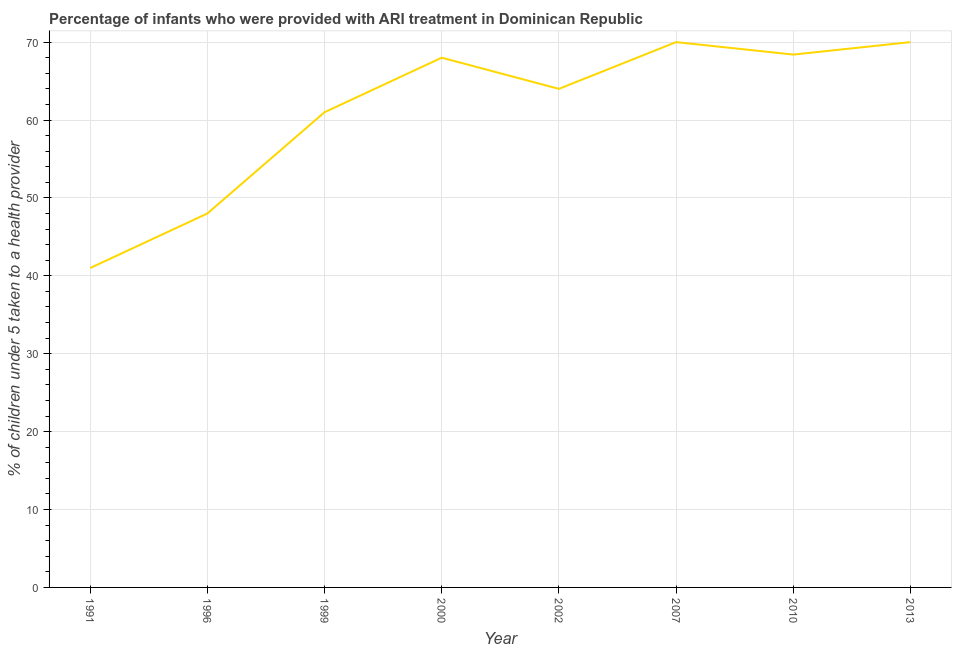What is the percentage of children who were provided with ari treatment in 2010?
Make the answer very short. 68.4. Across all years, what is the maximum percentage of children who were provided with ari treatment?
Your answer should be very brief. 70. In which year was the percentage of children who were provided with ari treatment minimum?
Your answer should be compact. 1991. What is the sum of the percentage of children who were provided with ari treatment?
Give a very brief answer. 490.4. What is the difference between the percentage of children who were provided with ari treatment in 1991 and 2010?
Your answer should be compact. -27.4. What is the average percentage of children who were provided with ari treatment per year?
Ensure brevity in your answer.  61.3. In how many years, is the percentage of children who were provided with ari treatment greater than 54 %?
Your response must be concise. 6. Do a majority of the years between 2000 and 2002 (inclusive) have percentage of children who were provided with ari treatment greater than 60 %?
Give a very brief answer. Yes. What is the ratio of the percentage of children who were provided with ari treatment in 2000 to that in 2013?
Your response must be concise. 0.97. What is the difference between the highest and the lowest percentage of children who were provided with ari treatment?
Ensure brevity in your answer.  29. In how many years, is the percentage of children who were provided with ari treatment greater than the average percentage of children who were provided with ari treatment taken over all years?
Your answer should be compact. 5. Are the values on the major ticks of Y-axis written in scientific E-notation?
Make the answer very short. No. What is the title of the graph?
Ensure brevity in your answer.  Percentage of infants who were provided with ARI treatment in Dominican Republic. What is the label or title of the Y-axis?
Provide a short and direct response. % of children under 5 taken to a health provider. What is the % of children under 5 taken to a health provider in 1991?
Your response must be concise. 41. What is the % of children under 5 taken to a health provider of 1999?
Your answer should be compact. 61. What is the % of children under 5 taken to a health provider in 2007?
Give a very brief answer. 70. What is the % of children under 5 taken to a health provider in 2010?
Your answer should be very brief. 68.4. What is the % of children under 5 taken to a health provider of 2013?
Keep it short and to the point. 70. What is the difference between the % of children under 5 taken to a health provider in 1991 and 1999?
Make the answer very short. -20. What is the difference between the % of children under 5 taken to a health provider in 1991 and 2000?
Your response must be concise. -27. What is the difference between the % of children under 5 taken to a health provider in 1991 and 2002?
Provide a short and direct response. -23. What is the difference between the % of children under 5 taken to a health provider in 1991 and 2010?
Offer a terse response. -27.4. What is the difference between the % of children under 5 taken to a health provider in 1991 and 2013?
Give a very brief answer. -29. What is the difference between the % of children under 5 taken to a health provider in 1996 and 2002?
Your answer should be compact. -16. What is the difference between the % of children under 5 taken to a health provider in 1996 and 2010?
Give a very brief answer. -20.4. What is the difference between the % of children under 5 taken to a health provider in 1999 and 2010?
Your response must be concise. -7.4. What is the difference between the % of children under 5 taken to a health provider in 2000 and 2013?
Offer a terse response. -2. What is the difference between the % of children under 5 taken to a health provider in 2002 and 2013?
Offer a terse response. -6. What is the difference between the % of children under 5 taken to a health provider in 2007 and 2013?
Your answer should be very brief. 0. What is the difference between the % of children under 5 taken to a health provider in 2010 and 2013?
Give a very brief answer. -1.6. What is the ratio of the % of children under 5 taken to a health provider in 1991 to that in 1996?
Your answer should be compact. 0.85. What is the ratio of the % of children under 5 taken to a health provider in 1991 to that in 1999?
Keep it short and to the point. 0.67. What is the ratio of the % of children under 5 taken to a health provider in 1991 to that in 2000?
Make the answer very short. 0.6. What is the ratio of the % of children under 5 taken to a health provider in 1991 to that in 2002?
Give a very brief answer. 0.64. What is the ratio of the % of children under 5 taken to a health provider in 1991 to that in 2007?
Your response must be concise. 0.59. What is the ratio of the % of children under 5 taken to a health provider in 1991 to that in 2010?
Make the answer very short. 0.6. What is the ratio of the % of children under 5 taken to a health provider in 1991 to that in 2013?
Your response must be concise. 0.59. What is the ratio of the % of children under 5 taken to a health provider in 1996 to that in 1999?
Provide a short and direct response. 0.79. What is the ratio of the % of children under 5 taken to a health provider in 1996 to that in 2000?
Your response must be concise. 0.71. What is the ratio of the % of children under 5 taken to a health provider in 1996 to that in 2002?
Your response must be concise. 0.75. What is the ratio of the % of children under 5 taken to a health provider in 1996 to that in 2007?
Offer a very short reply. 0.69. What is the ratio of the % of children under 5 taken to a health provider in 1996 to that in 2010?
Ensure brevity in your answer.  0.7. What is the ratio of the % of children under 5 taken to a health provider in 1996 to that in 2013?
Make the answer very short. 0.69. What is the ratio of the % of children under 5 taken to a health provider in 1999 to that in 2000?
Make the answer very short. 0.9. What is the ratio of the % of children under 5 taken to a health provider in 1999 to that in 2002?
Offer a very short reply. 0.95. What is the ratio of the % of children under 5 taken to a health provider in 1999 to that in 2007?
Offer a terse response. 0.87. What is the ratio of the % of children under 5 taken to a health provider in 1999 to that in 2010?
Offer a terse response. 0.89. What is the ratio of the % of children under 5 taken to a health provider in 1999 to that in 2013?
Ensure brevity in your answer.  0.87. What is the ratio of the % of children under 5 taken to a health provider in 2000 to that in 2002?
Keep it short and to the point. 1.06. What is the ratio of the % of children under 5 taken to a health provider in 2002 to that in 2007?
Offer a terse response. 0.91. What is the ratio of the % of children under 5 taken to a health provider in 2002 to that in 2010?
Ensure brevity in your answer.  0.94. What is the ratio of the % of children under 5 taken to a health provider in 2002 to that in 2013?
Your response must be concise. 0.91. What is the ratio of the % of children under 5 taken to a health provider in 2007 to that in 2013?
Make the answer very short. 1. 